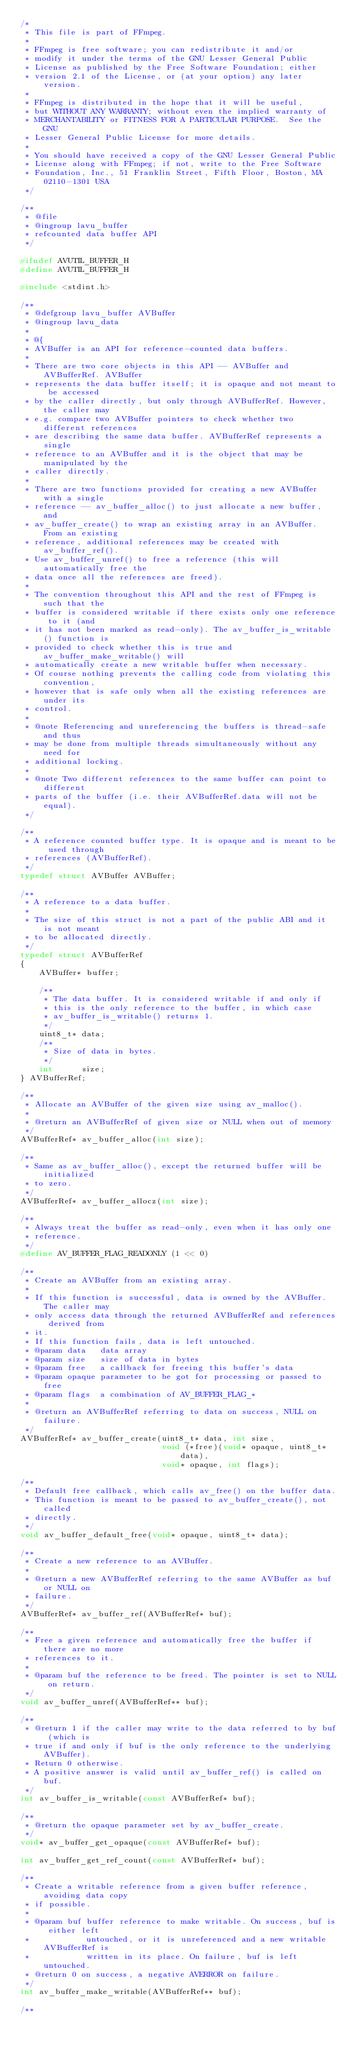<code> <loc_0><loc_0><loc_500><loc_500><_C_>/*
 * This file is part of FFmpeg.
 *
 * FFmpeg is free software; you can redistribute it and/or
 * modify it under the terms of the GNU Lesser General Public
 * License as published by the Free Software Foundation; either
 * version 2.1 of the License, or (at your option) any later version.
 *
 * FFmpeg is distributed in the hope that it will be useful,
 * but WITHOUT ANY WARRANTY; without even the implied warranty of
 * MERCHANTABILITY or FITNESS FOR A PARTICULAR PURPOSE.  See the GNU
 * Lesser General Public License for more details.
 *
 * You should have received a copy of the GNU Lesser General Public
 * License along with FFmpeg; if not, write to the Free Software
 * Foundation, Inc., 51 Franklin Street, Fifth Floor, Boston, MA 02110-1301 USA
 */

/**
 * @file
 * @ingroup lavu_buffer
 * refcounted data buffer API
 */

#ifndef AVUTIL_BUFFER_H
#define AVUTIL_BUFFER_H

#include <stdint.h>

/**
 * @defgroup lavu_buffer AVBuffer
 * @ingroup lavu_data
 *
 * @{
 * AVBuffer is an API for reference-counted data buffers.
 *
 * There are two core objects in this API -- AVBuffer and AVBufferRef. AVBuffer
 * represents the data buffer itself; it is opaque and not meant to be accessed
 * by the caller directly, but only through AVBufferRef. However, the caller may
 * e.g. compare two AVBuffer pointers to check whether two different references
 * are describing the same data buffer. AVBufferRef represents a single
 * reference to an AVBuffer and it is the object that may be manipulated by the
 * caller directly.
 *
 * There are two functions provided for creating a new AVBuffer with a single
 * reference -- av_buffer_alloc() to just allocate a new buffer, and
 * av_buffer_create() to wrap an existing array in an AVBuffer. From an existing
 * reference, additional references may be created with av_buffer_ref().
 * Use av_buffer_unref() to free a reference (this will automatically free the
 * data once all the references are freed).
 *
 * The convention throughout this API and the rest of FFmpeg is such that the
 * buffer is considered writable if there exists only one reference to it (and
 * it has not been marked as read-only). The av_buffer_is_writable() function is
 * provided to check whether this is true and av_buffer_make_writable() will
 * automatically create a new writable buffer when necessary.
 * Of course nothing prevents the calling code from violating this convention,
 * however that is safe only when all the existing references are under its
 * control.
 *
 * @note Referencing and unreferencing the buffers is thread-safe and thus
 * may be done from multiple threads simultaneously without any need for
 * additional locking.
 *
 * @note Two different references to the same buffer can point to different
 * parts of the buffer (i.e. their AVBufferRef.data will not be equal).
 */

/**
 * A reference counted buffer type. It is opaque and is meant to be used through
 * references (AVBufferRef).
 */
typedef struct AVBuffer AVBuffer;

/**
 * A reference to a data buffer.
 *
 * The size of this struct is not a part of the public ABI and it is not meant
 * to be allocated directly.
 */
typedef struct AVBufferRef
{
    AVBuffer* buffer;

    /**
     * The data buffer. It is considered writable if and only if
     * this is the only reference to the buffer, in which case
     * av_buffer_is_writable() returns 1.
     */
    uint8_t* data;
    /**
     * Size of data in bytes.
     */
    int      size;
} AVBufferRef;

/**
 * Allocate an AVBuffer of the given size using av_malloc().
 *
 * @return an AVBufferRef of given size or NULL when out of memory
 */
AVBufferRef* av_buffer_alloc(int size);

/**
 * Same as av_buffer_alloc(), except the returned buffer will be initialized
 * to zero.
 */
AVBufferRef* av_buffer_allocz(int size);

/**
 * Always treat the buffer as read-only, even when it has only one
 * reference.
 */
#define AV_BUFFER_FLAG_READONLY (1 << 0)

/**
 * Create an AVBuffer from an existing array.
 *
 * If this function is successful, data is owned by the AVBuffer. The caller may
 * only access data through the returned AVBufferRef and references derived from
 * it.
 * If this function fails, data is left untouched.
 * @param data   data array
 * @param size   size of data in bytes
 * @param free   a callback for freeing this buffer's data
 * @param opaque parameter to be got for processing or passed to free
 * @param flags  a combination of AV_BUFFER_FLAG_*
 *
 * @return an AVBufferRef referring to data on success, NULL on failure.
 */
AVBufferRef* av_buffer_create(uint8_t* data, int size,
                              void (*free)(void* opaque, uint8_t* data),
                              void* opaque, int flags);

/**
 * Default free callback, which calls av_free() on the buffer data.
 * This function is meant to be passed to av_buffer_create(), not called
 * directly.
 */
void av_buffer_default_free(void* opaque, uint8_t* data);

/**
 * Create a new reference to an AVBuffer.
 *
 * @return a new AVBufferRef referring to the same AVBuffer as buf or NULL on
 * failure.
 */
AVBufferRef* av_buffer_ref(AVBufferRef* buf);

/**
 * Free a given reference and automatically free the buffer if there are no more
 * references to it.
 *
 * @param buf the reference to be freed. The pointer is set to NULL on return.
 */
void av_buffer_unref(AVBufferRef** buf);

/**
 * @return 1 if the caller may write to the data referred to by buf (which is
 * true if and only if buf is the only reference to the underlying AVBuffer).
 * Return 0 otherwise.
 * A positive answer is valid until av_buffer_ref() is called on buf.
 */
int av_buffer_is_writable(const AVBufferRef* buf);

/**
 * @return the opaque parameter set by av_buffer_create.
 */
void* av_buffer_get_opaque(const AVBufferRef* buf);

int av_buffer_get_ref_count(const AVBufferRef* buf);

/**
 * Create a writable reference from a given buffer reference, avoiding data copy
 * if possible.
 *
 * @param buf buffer reference to make writable. On success, buf is either left
 *            untouched, or it is unreferenced and a new writable AVBufferRef is
 *            written in its place. On failure, buf is left untouched.
 * @return 0 on success, a negative AVERROR on failure.
 */
int av_buffer_make_writable(AVBufferRef** buf);

/**</code> 